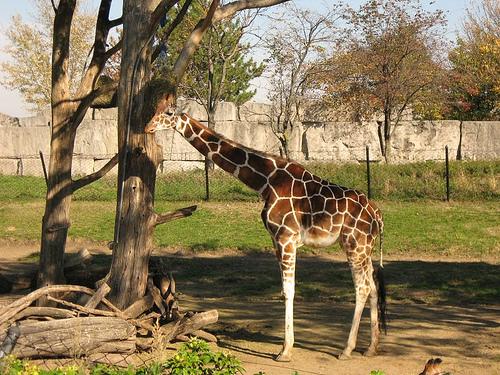Are there any rocks by the giraffe?
Write a very short answer. No. Where is the giraffe?
Answer briefly. Zoo. Can you see birds?
Write a very short answer. No. Does this animal have eyelashes?
Answer briefly. Yes. How many giraffe are there?
Keep it brief. 1. How many animals are in this photo?
Quick response, please. 1. Is the giraffe eating the tree?
Short answer required. No. 